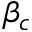<formula> <loc_0><loc_0><loc_500><loc_500>\beta _ { c }</formula> 